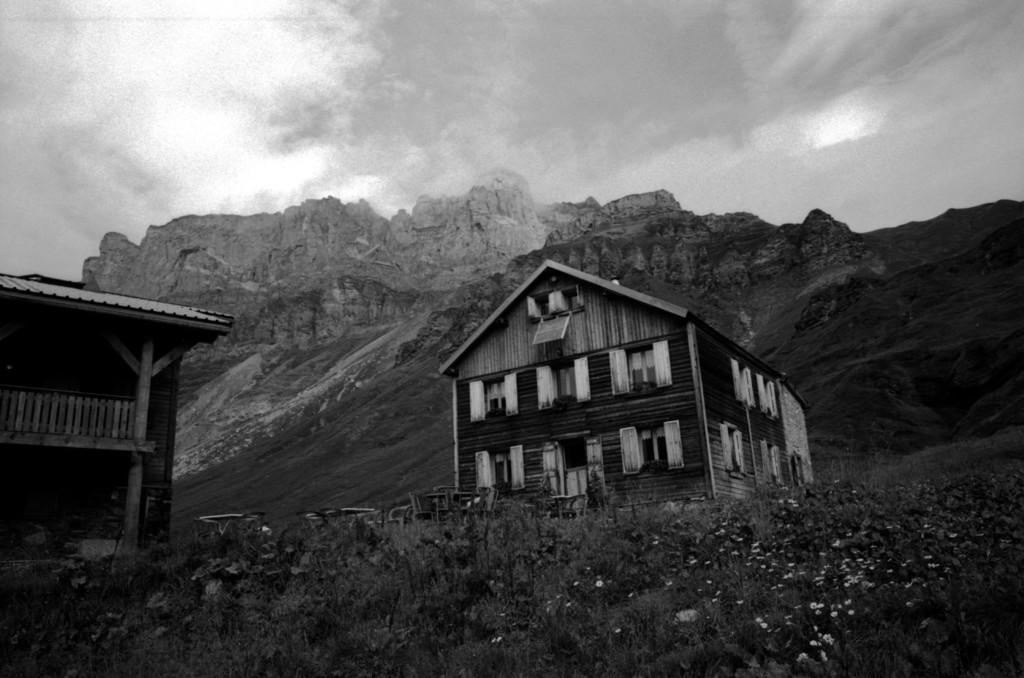What type of structures are visible in the image? There are houses in the image. What other elements can be seen in the image besides the houses? There are plants in the image. Where are the plants located in relation to the houses? The plants are at the foreground of the image. What can be seen in the distance behind the houses and plants? There are mountains in the background of the image. How would you describe the sky in the image? The sky is cloudy in the background of the image. What type of toys can be seen in the image? There are no toys present in the image. What is the plant's interest in the image? Plants do not have interests, as they are inanimate objects. 